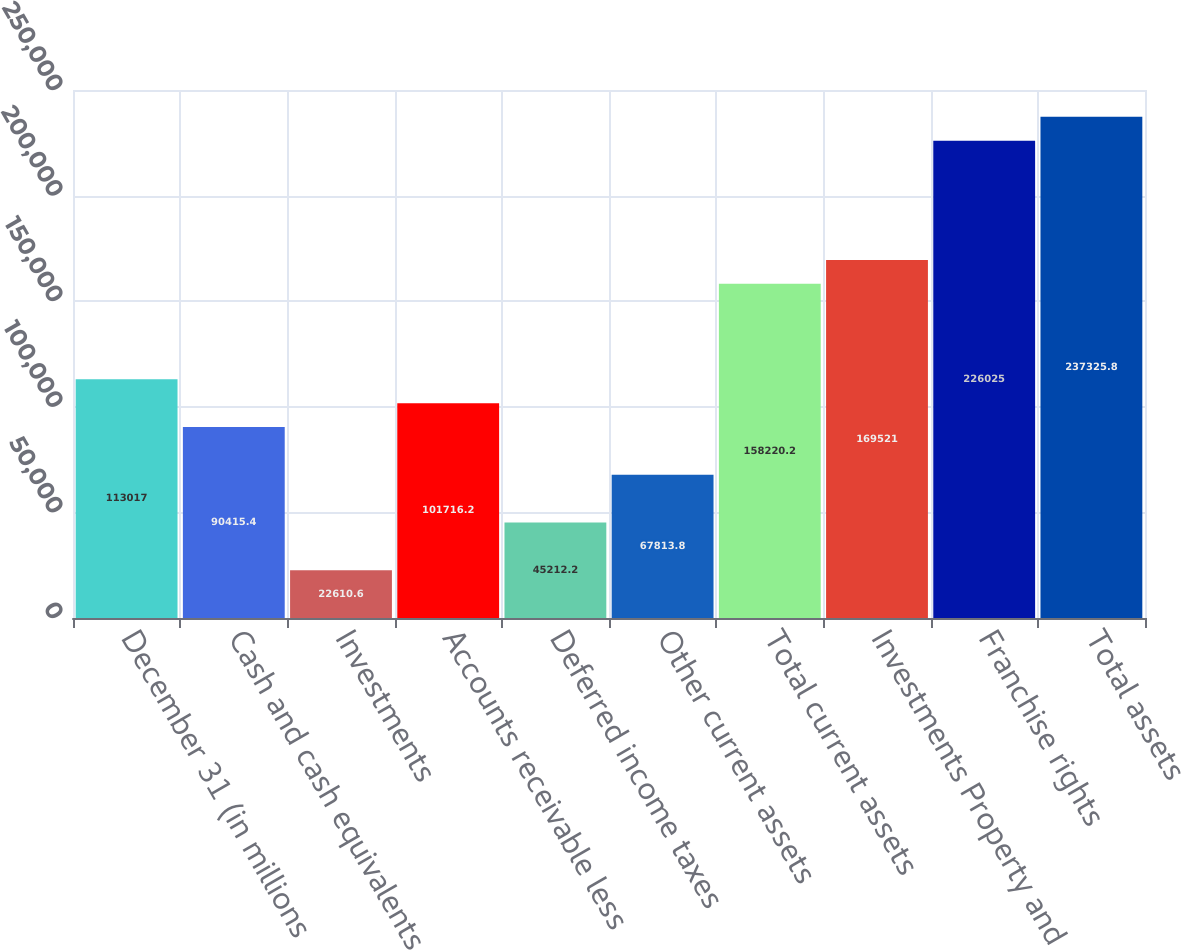Convert chart to OTSL. <chart><loc_0><loc_0><loc_500><loc_500><bar_chart><fcel>December 31 (in millions<fcel>Cash and cash equivalents<fcel>Investments<fcel>Accounts receivable less<fcel>Deferred income taxes<fcel>Other current assets<fcel>Total current assets<fcel>Investments Property and<fcel>Franchise rights<fcel>Total assets<nl><fcel>113017<fcel>90415.4<fcel>22610.6<fcel>101716<fcel>45212.2<fcel>67813.8<fcel>158220<fcel>169521<fcel>226025<fcel>237326<nl></chart> 